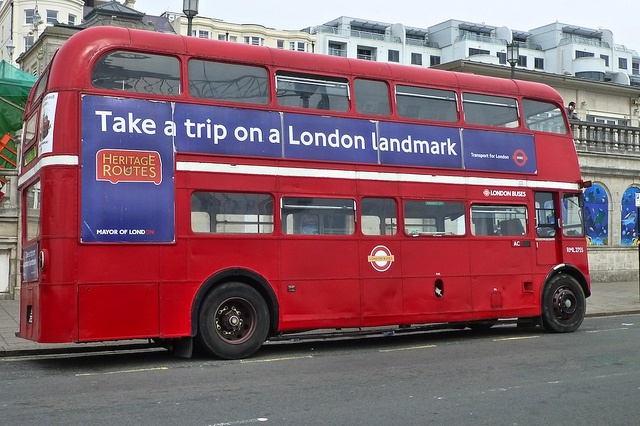Describe the objects in this image and their specific colors. I can see bus in lavender, brown, blue, gray, and black tones in this image. 